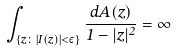<formula> <loc_0><loc_0><loc_500><loc_500>\int _ { \{ z \colon | I ( z ) | < \varepsilon \} } \frac { d A ( z ) } { 1 - | z | ^ { 2 } } = \infty</formula> 